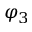Convert formula to latex. <formula><loc_0><loc_0><loc_500><loc_500>\varphi _ { 3 }</formula> 